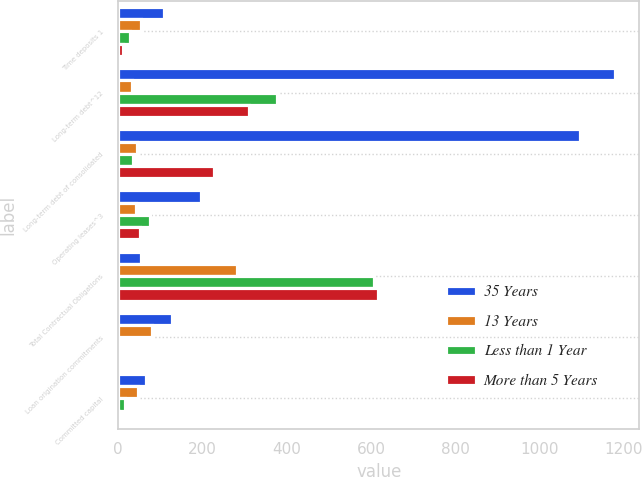Convert chart to OTSL. <chart><loc_0><loc_0><loc_500><loc_500><stacked_bar_chart><ecel><fcel>Time deposits 1<fcel>Long-term debt^12<fcel>Long-term debt of consolidated<fcel>Operating leases^3<fcel>Total Contractual Obligations<fcel>Loan origination commitments<fcel>Committed capital<nl><fcel>35 Years<fcel>109.8<fcel>1178.1<fcel>1096.7<fcel>197<fcel>54.3<fcel>128.2<fcel>67.2<nl><fcel>13 Years<fcel>54.3<fcel>32.3<fcel>44<fcel>43.1<fcel>282.9<fcel>80.1<fcel>46.8<nl><fcel>Less than 1 Year<fcel>28.4<fcel>376.2<fcel>36.5<fcel>74.7<fcel>608.2<fcel>0.7<fcel>17.2<nl><fcel>More than 5 Years<fcel>12<fcel>311.5<fcel>227.3<fcel>51<fcel>615.9<fcel>4.1<fcel>3<nl></chart> 